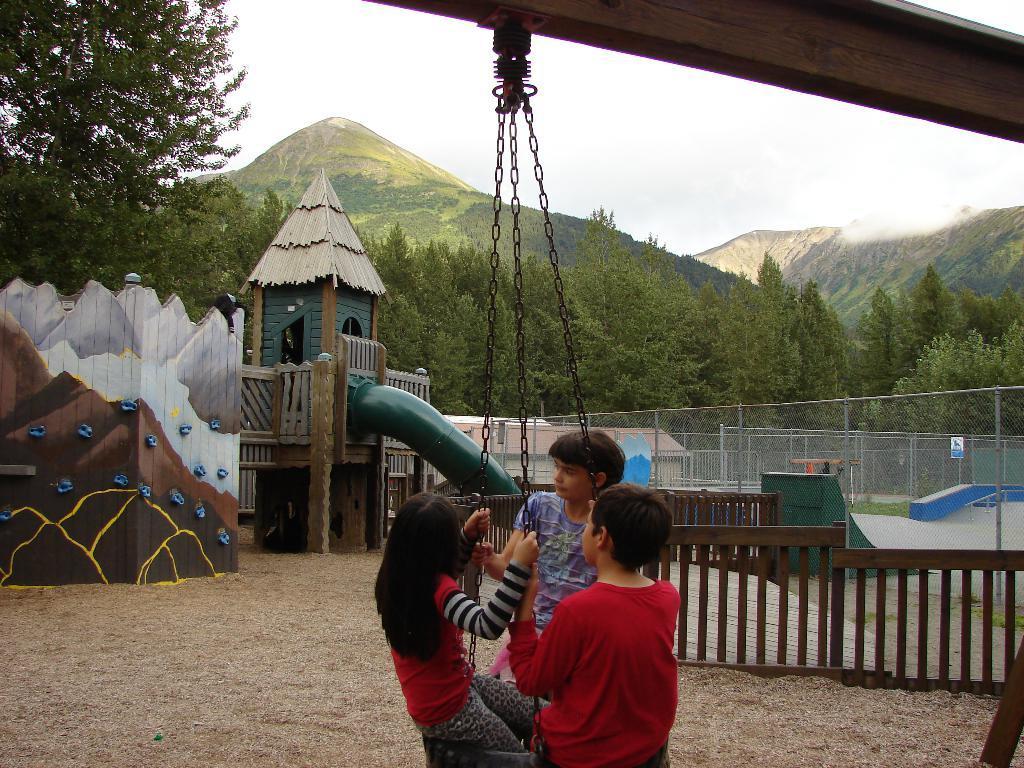How would you summarize this image in a sentence or two? In this image there are playground objects, wall, mesh, building, railings, board, trees, hills, sky, chains, children, swing and objects. Near the chains there are three children.  